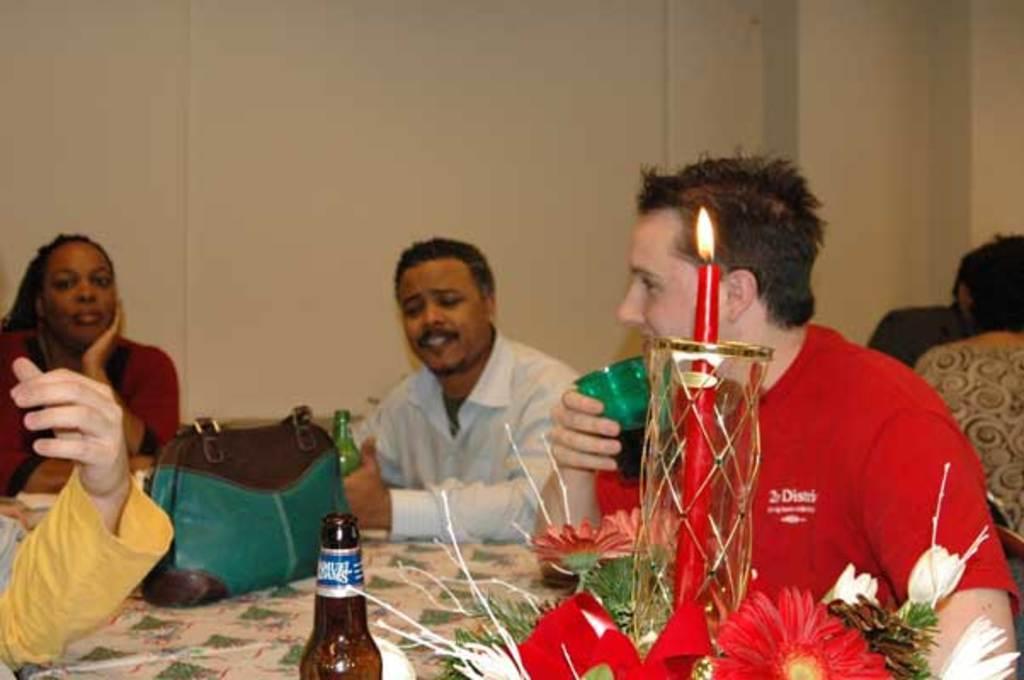Please provide a concise description of this image. This persons are sitting on a chair. In-front of this person there is a table, on table there is a bag, bottles, bouquet and candle with light. This man is holding a glass. 